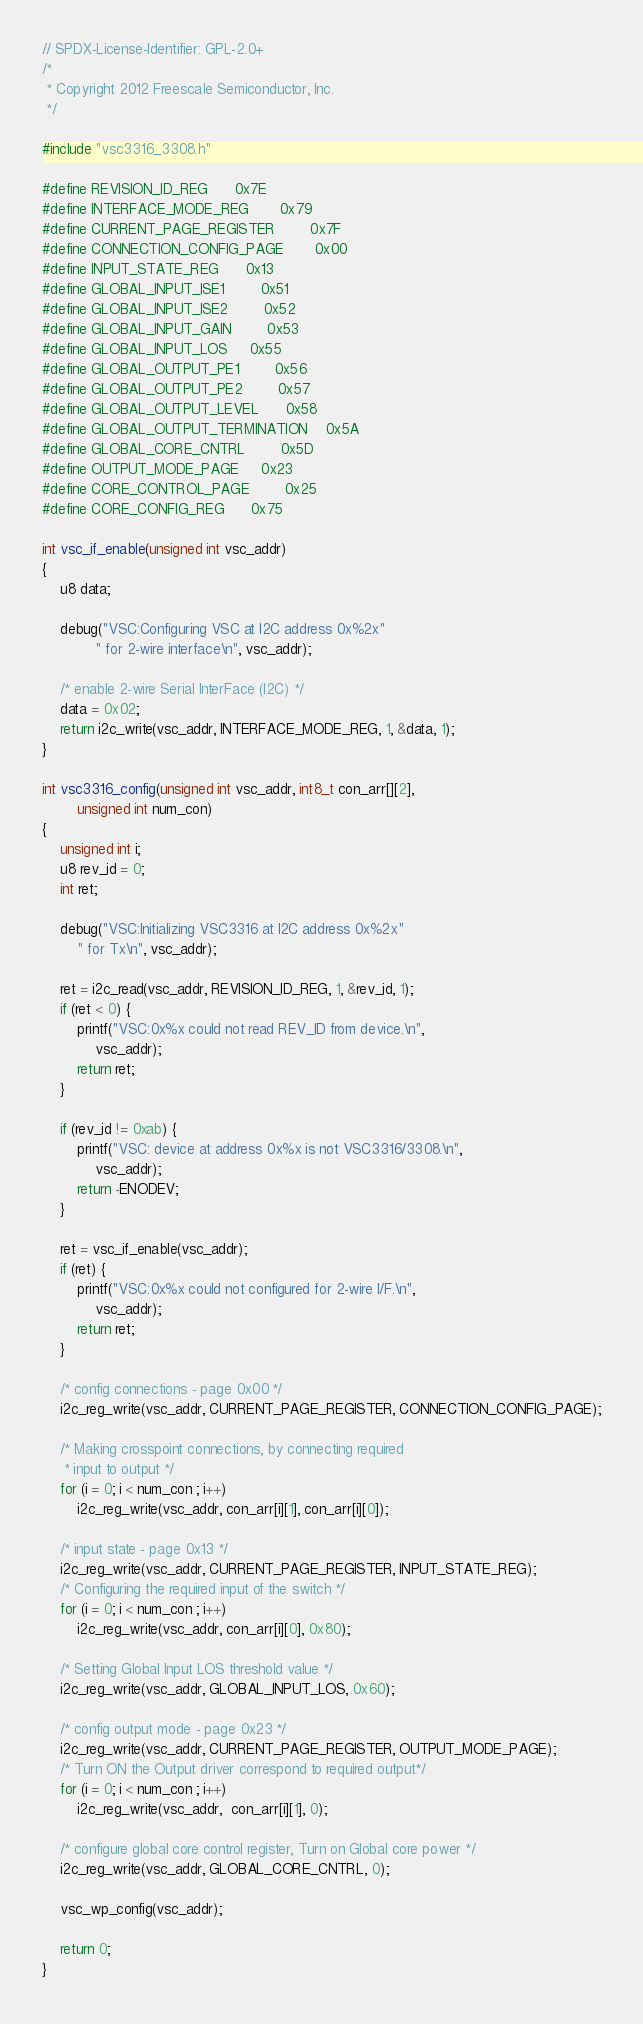<code> <loc_0><loc_0><loc_500><loc_500><_C_>// SPDX-License-Identifier: GPL-2.0+
/*
 * Copyright 2012 Freescale Semiconductor, Inc.
 */

#include "vsc3316_3308.h"

#define REVISION_ID_REG		0x7E
#define INTERFACE_MODE_REG		0x79
#define CURRENT_PAGE_REGISTER		0x7F
#define CONNECTION_CONFIG_PAGE		0x00
#define INPUT_STATE_REG		0x13
#define GLOBAL_INPUT_ISE1		0x51
#define GLOBAL_INPUT_ISE2		0x52
#define GLOBAL_INPUT_GAIN		0x53
#define GLOBAL_INPUT_LOS		0x55
#define GLOBAL_OUTPUT_PE1		0x56
#define GLOBAL_OUTPUT_PE2		0x57
#define GLOBAL_OUTPUT_LEVEL		0x58
#define GLOBAL_OUTPUT_TERMINATION	0x5A
#define GLOBAL_CORE_CNTRL		0x5D
#define OUTPUT_MODE_PAGE		0x23
#define CORE_CONTROL_PAGE		0x25
#define CORE_CONFIG_REG		0x75

int vsc_if_enable(unsigned int vsc_addr)
{
	u8 data;

	debug("VSC:Configuring VSC at I2C address 0x%2x"
			" for 2-wire interface\n", vsc_addr);

	/* enable 2-wire Serial InterFace (I2C) */
	data = 0x02;
	return i2c_write(vsc_addr, INTERFACE_MODE_REG, 1, &data, 1);
}

int vsc3316_config(unsigned int vsc_addr, int8_t con_arr[][2],
		unsigned int num_con)
{
	unsigned int i;
	u8 rev_id = 0;
	int ret;

	debug("VSC:Initializing VSC3316 at I2C address 0x%2x"
		" for Tx\n", vsc_addr);

	ret = i2c_read(vsc_addr, REVISION_ID_REG, 1, &rev_id, 1);
	if (ret < 0) {
		printf("VSC:0x%x could not read REV_ID from device.\n",
			vsc_addr);
		return ret;
	}

	if (rev_id != 0xab) {
		printf("VSC: device at address 0x%x is not VSC3316/3308.\n",
			vsc_addr);
		return -ENODEV;
	}

	ret = vsc_if_enable(vsc_addr);
	if (ret) {
		printf("VSC:0x%x could not configured for 2-wire I/F.\n",
			vsc_addr);
		return ret;
	}

	/* config connections - page 0x00 */
	i2c_reg_write(vsc_addr, CURRENT_PAGE_REGISTER, CONNECTION_CONFIG_PAGE);

	/* Making crosspoint connections, by connecting required
	 * input to output */
	for (i = 0; i < num_con ; i++)
		i2c_reg_write(vsc_addr, con_arr[i][1], con_arr[i][0]);

	/* input state - page 0x13 */
	i2c_reg_write(vsc_addr, CURRENT_PAGE_REGISTER, INPUT_STATE_REG);
	/* Configuring the required input of the switch */
	for (i = 0; i < num_con ; i++)
		i2c_reg_write(vsc_addr, con_arr[i][0], 0x80);

	/* Setting Global Input LOS threshold value */
	i2c_reg_write(vsc_addr, GLOBAL_INPUT_LOS, 0x60);

	/* config output mode - page 0x23 */
	i2c_reg_write(vsc_addr, CURRENT_PAGE_REGISTER, OUTPUT_MODE_PAGE);
	/* Turn ON the Output driver correspond to required output*/
	for (i = 0; i < num_con ; i++)
		i2c_reg_write(vsc_addr,  con_arr[i][1], 0);

	/* configure global core control register, Turn on Global core power */
	i2c_reg_write(vsc_addr, GLOBAL_CORE_CNTRL, 0);

	vsc_wp_config(vsc_addr);

	return 0;
}
</code> 